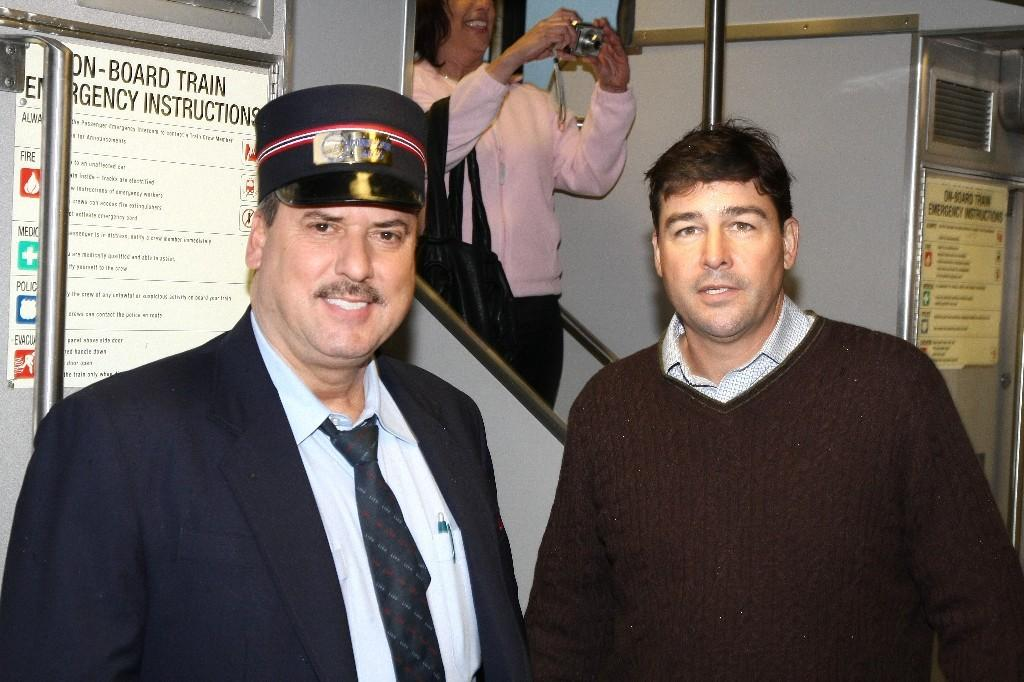How many men are present in the image? There are two men standing in the image. Can you describe the clothing of one of the men? One of the men is wearing a cap. What is the woman in the background of the image doing? The woman is holding a camera. What object can be seen in the image besides the people? There is a board visible in the image. What type of magic is the man performing with his sister in the image? There is no mention of a sister or any magic in the image; it only shows two men and a woman with a camera. 